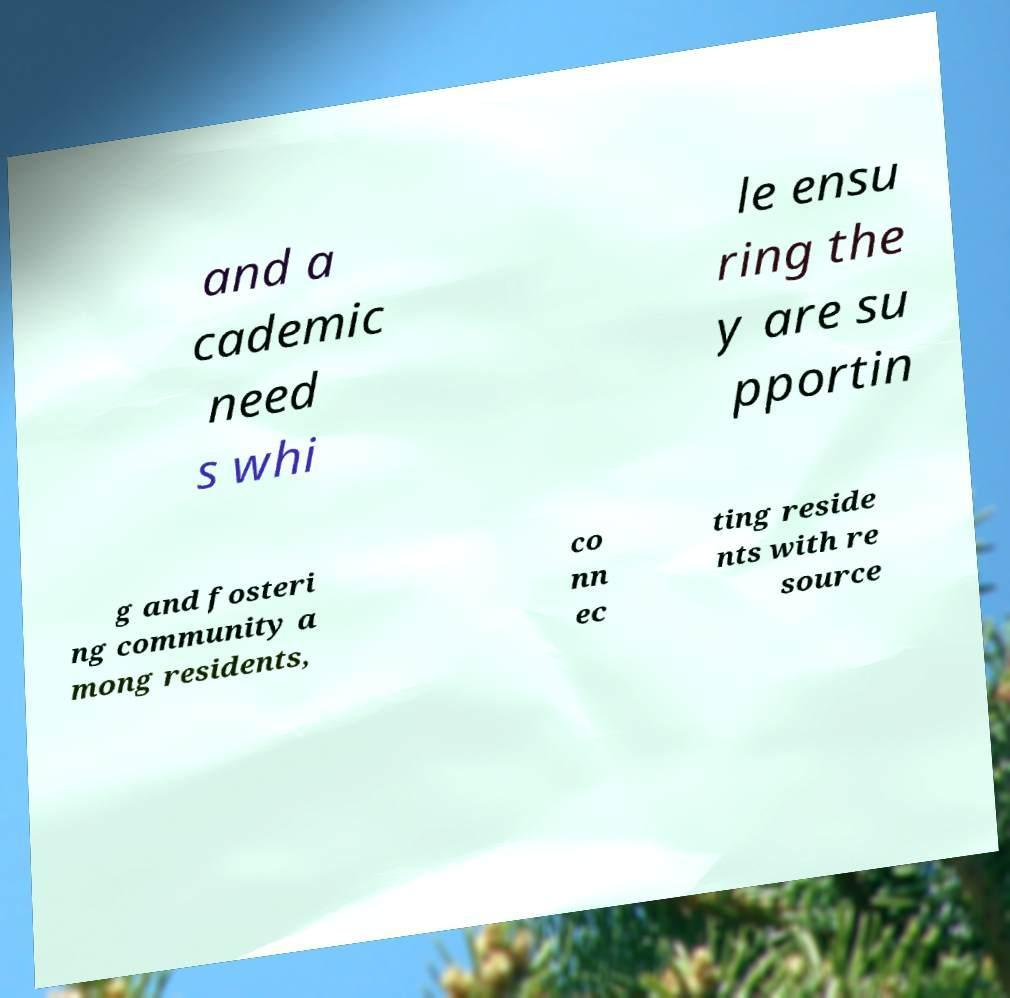Could you extract and type out the text from this image? and a cademic need s whi le ensu ring the y are su pportin g and fosteri ng community a mong residents, co nn ec ting reside nts with re source 